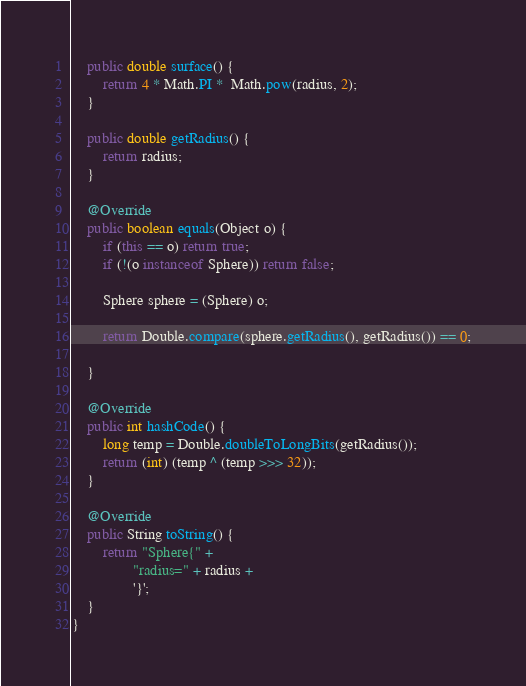Convert code to text. <code><loc_0><loc_0><loc_500><loc_500><_Java_>    public double surface() {
        return 4 * Math.PI *  Math.pow(radius, 2);
    }

    public double getRadius() {
        return radius;
    }

    @Override
    public boolean equals(Object o) {
        if (this == o) return true;
        if (!(o instanceof Sphere)) return false;

        Sphere sphere = (Sphere) o;

        return Double.compare(sphere.getRadius(), getRadius()) == 0;

    }

    @Override
    public int hashCode() {
        long temp = Double.doubleToLongBits(getRadius());
        return (int) (temp ^ (temp >>> 32));
    }

    @Override
    public String toString() {
        return "Sphere{" +
                "radius=" + radius +
                '}';
    }
}
</code> 